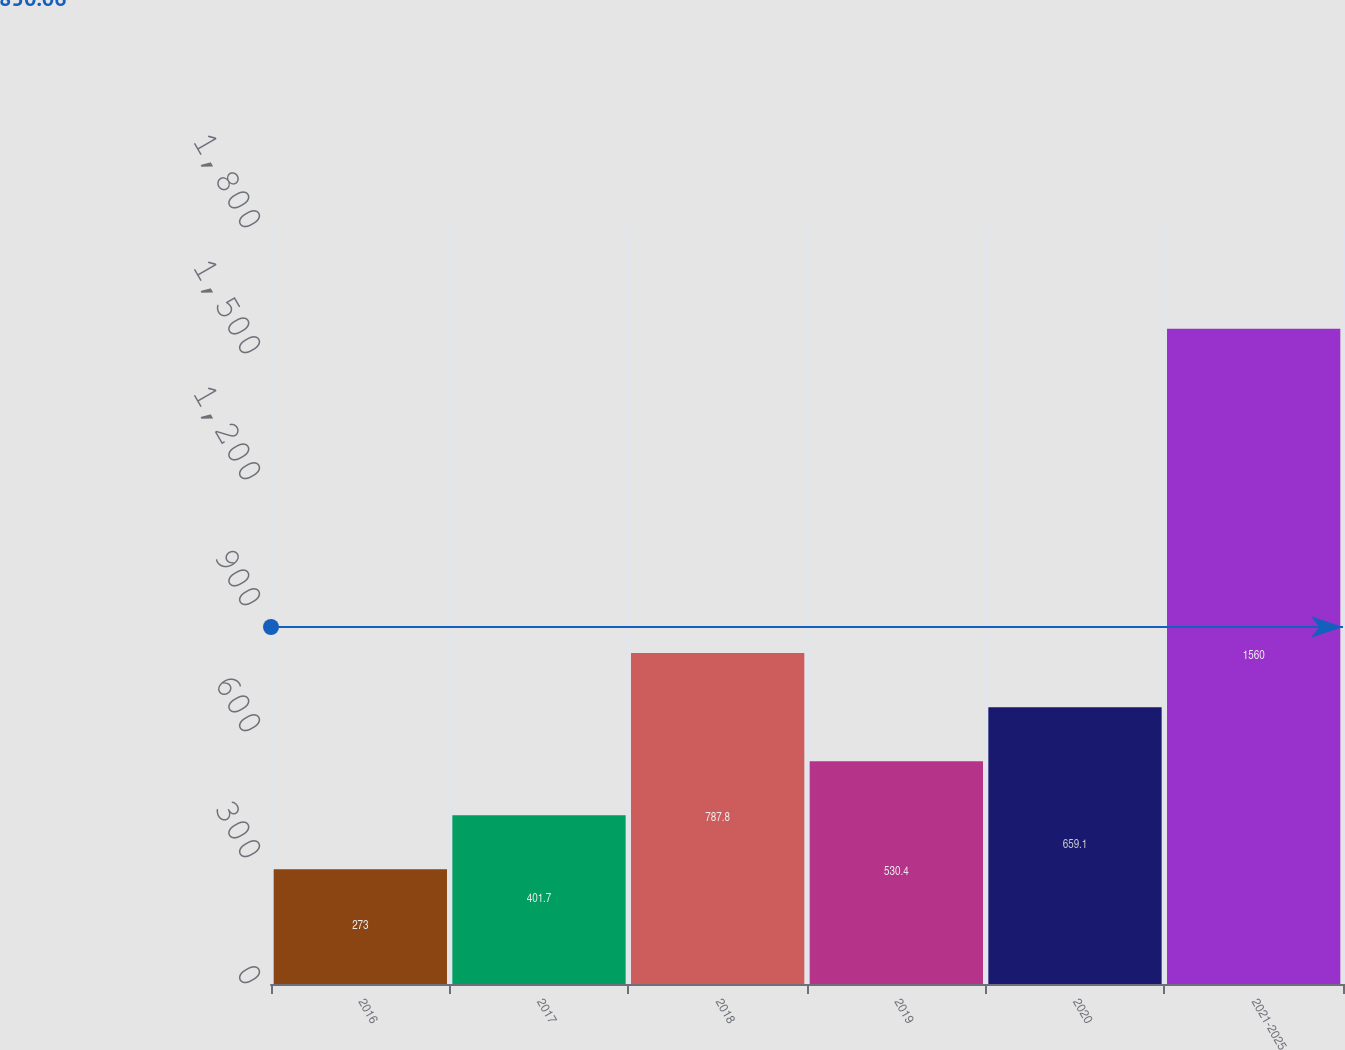<chart> <loc_0><loc_0><loc_500><loc_500><bar_chart><fcel>2016<fcel>2017<fcel>2018<fcel>2019<fcel>2020<fcel>2021-2025<nl><fcel>273<fcel>401.7<fcel>787.8<fcel>530.4<fcel>659.1<fcel>1560<nl></chart> 